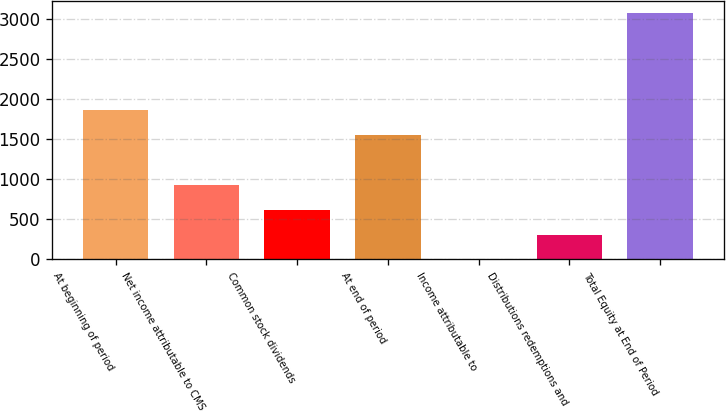<chart> <loc_0><loc_0><loc_500><loc_500><bar_chart><fcel>At beginning of period<fcel>Net income attributable to CMS<fcel>Common stock dividends<fcel>At end of period<fcel>Income attributable to<fcel>Distributions redemptions and<fcel>Total Equity at End of Period<nl><fcel>1860<fcel>923<fcel>616<fcel>1553<fcel>2<fcel>309<fcel>3072<nl></chart> 